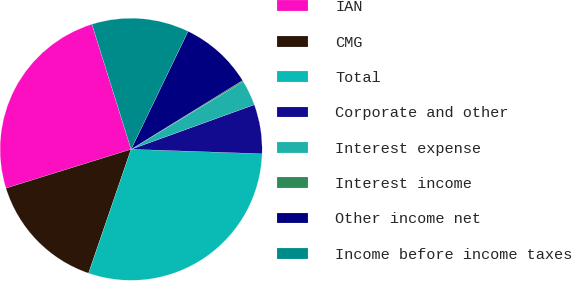<chart> <loc_0><loc_0><loc_500><loc_500><pie_chart><fcel>IAN<fcel>CMG<fcel>Total<fcel>Corporate and other<fcel>Interest expense<fcel>Interest income<fcel>Other income net<fcel>Income before income taxes<nl><fcel>24.97%<fcel>14.94%<fcel>29.72%<fcel>6.07%<fcel>3.12%<fcel>0.16%<fcel>9.03%<fcel>11.99%<nl></chart> 